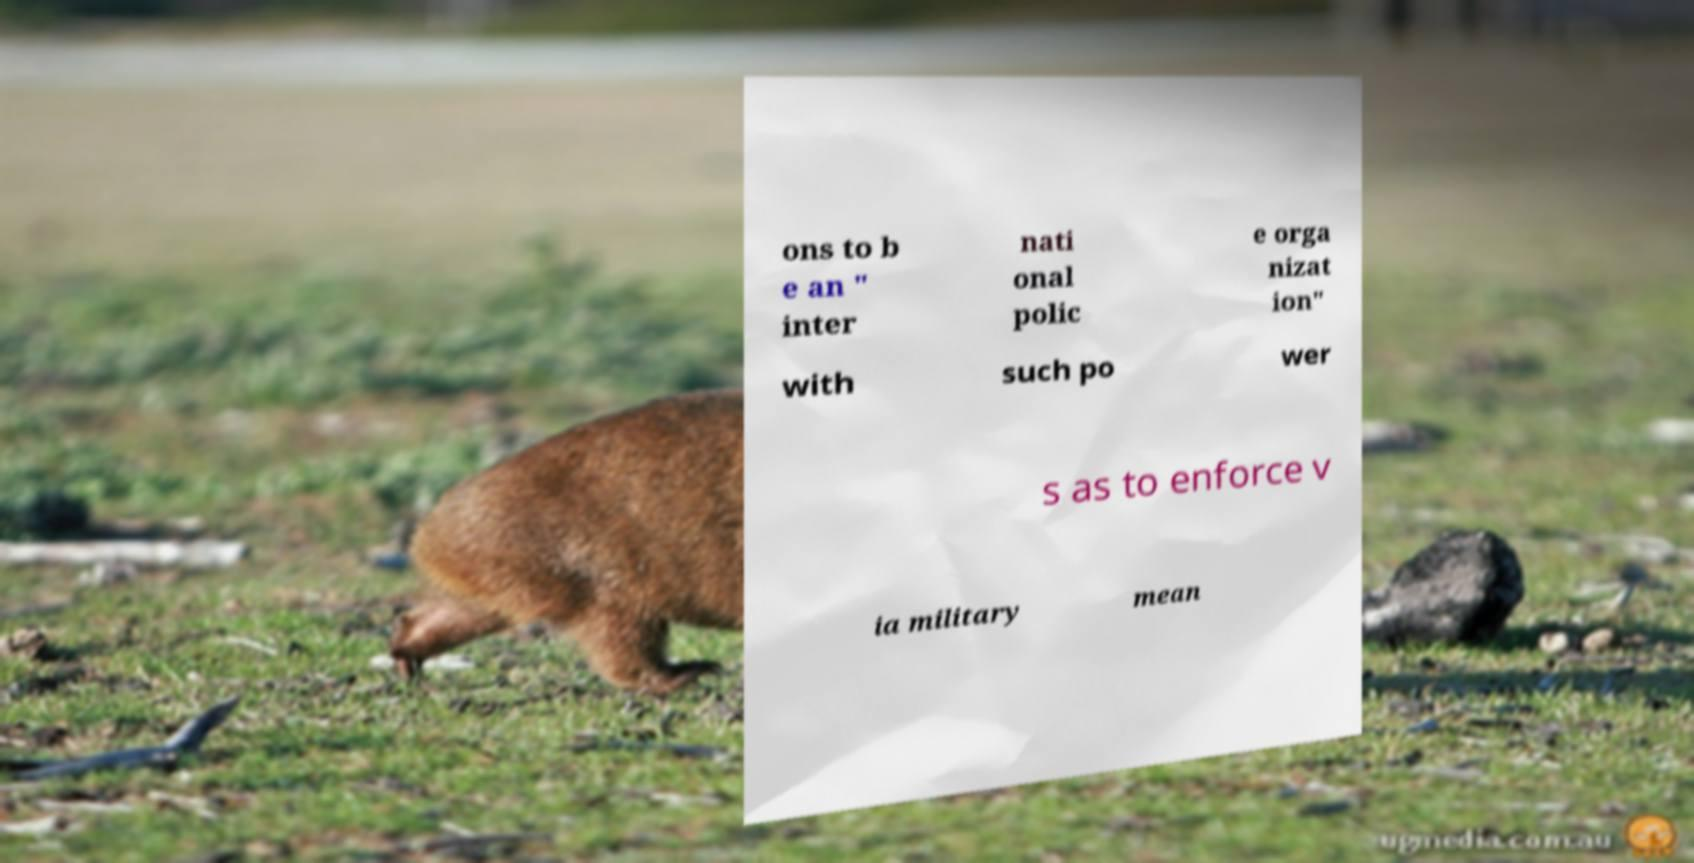What messages or text are displayed in this image? I need them in a readable, typed format. ons to b e an " inter nati onal polic e orga nizat ion" with such po wer s as to enforce v ia military mean 